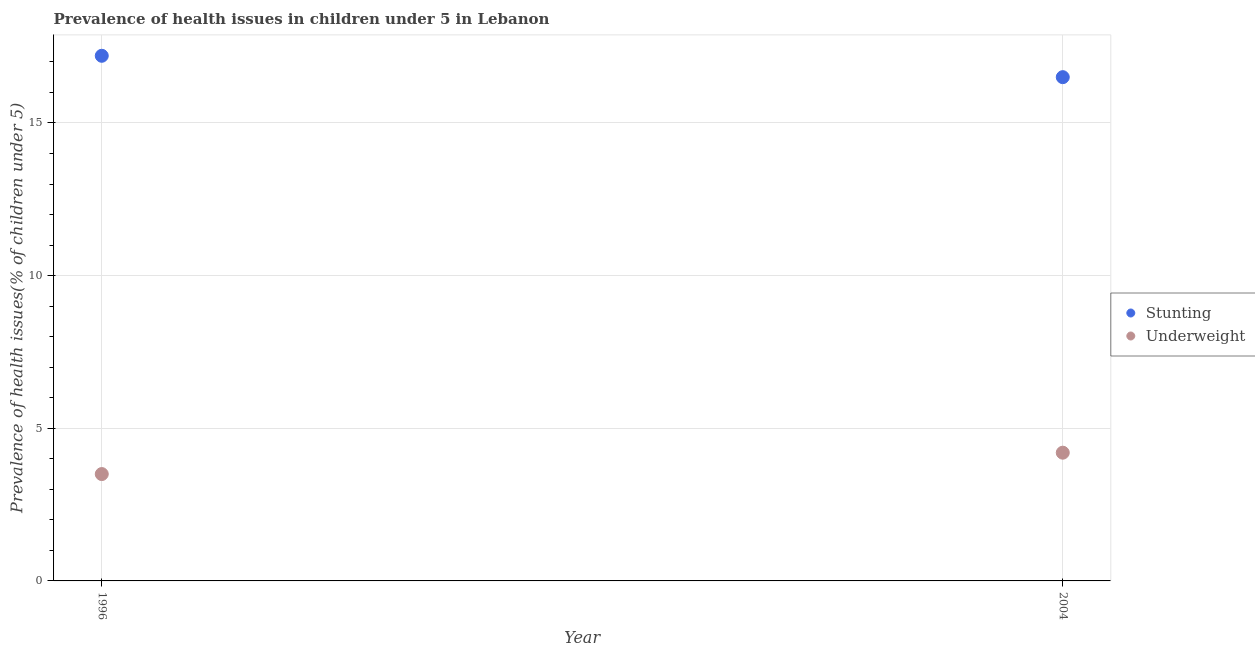How many different coloured dotlines are there?
Ensure brevity in your answer.  2. Across all years, what is the maximum percentage of stunted children?
Your response must be concise. 17.2. What is the total percentage of underweight children in the graph?
Your answer should be compact. 7.7. What is the difference between the percentage of stunted children in 1996 and that in 2004?
Offer a very short reply. 0.7. What is the average percentage of underweight children per year?
Keep it short and to the point. 3.85. In the year 1996, what is the difference between the percentage of stunted children and percentage of underweight children?
Offer a terse response. 13.7. In how many years, is the percentage of stunted children greater than 10 %?
Keep it short and to the point. 2. What is the ratio of the percentage of stunted children in 1996 to that in 2004?
Provide a succinct answer. 1.04. Is the percentage of stunted children in 1996 less than that in 2004?
Your answer should be compact. No. Does the percentage of stunted children monotonically increase over the years?
Provide a succinct answer. No. Is the percentage of stunted children strictly less than the percentage of underweight children over the years?
Provide a succinct answer. No. How many years are there in the graph?
Ensure brevity in your answer.  2. Does the graph contain grids?
Provide a succinct answer. Yes. How are the legend labels stacked?
Provide a short and direct response. Vertical. What is the title of the graph?
Make the answer very short. Prevalence of health issues in children under 5 in Lebanon. Does "Borrowers" appear as one of the legend labels in the graph?
Your response must be concise. No. What is the label or title of the X-axis?
Ensure brevity in your answer.  Year. What is the label or title of the Y-axis?
Your answer should be compact. Prevalence of health issues(% of children under 5). What is the Prevalence of health issues(% of children under 5) of Stunting in 1996?
Ensure brevity in your answer.  17.2. What is the Prevalence of health issues(% of children under 5) in Underweight in 2004?
Your answer should be compact. 4.2. Across all years, what is the maximum Prevalence of health issues(% of children under 5) of Stunting?
Offer a very short reply. 17.2. Across all years, what is the maximum Prevalence of health issues(% of children under 5) of Underweight?
Offer a very short reply. 4.2. Across all years, what is the minimum Prevalence of health issues(% of children under 5) in Stunting?
Give a very brief answer. 16.5. Across all years, what is the minimum Prevalence of health issues(% of children under 5) of Underweight?
Make the answer very short. 3.5. What is the total Prevalence of health issues(% of children under 5) of Stunting in the graph?
Offer a very short reply. 33.7. What is the total Prevalence of health issues(% of children under 5) in Underweight in the graph?
Offer a terse response. 7.7. What is the average Prevalence of health issues(% of children under 5) in Stunting per year?
Make the answer very short. 16.85. What is the average Prevalence of health issues(% of children under 5) of Underweight per year?
Your answer should be compact. 3.85. In the year 2004, what is the difference between the Prevalence of health issues(% of children under 5) in Stunting and Prevalence of health issues(% of children under 5) in Underweight?
Give a very brief answer. 12.3. What is the ratio of the Prevalence of health issues(% of children under 5) of Stunting in 1996 to that in 2004?
Offer a very short reply. 1.04. What is the ratio of the Prevalence of health issues(% of children under 5) of Underweight in 1996 to that in 2004?
Provide a succinct answer. 0.83. What is the difference between the highest and the second highest Prevalence of health issues(% of children under 5) of Underweight?
Your answer should be compact. 0.7. What is the difference between the highest and the lowest Prevalence of health issues(% of children under 5) in Underweight?
Provide a short and direct response. 0.7. 